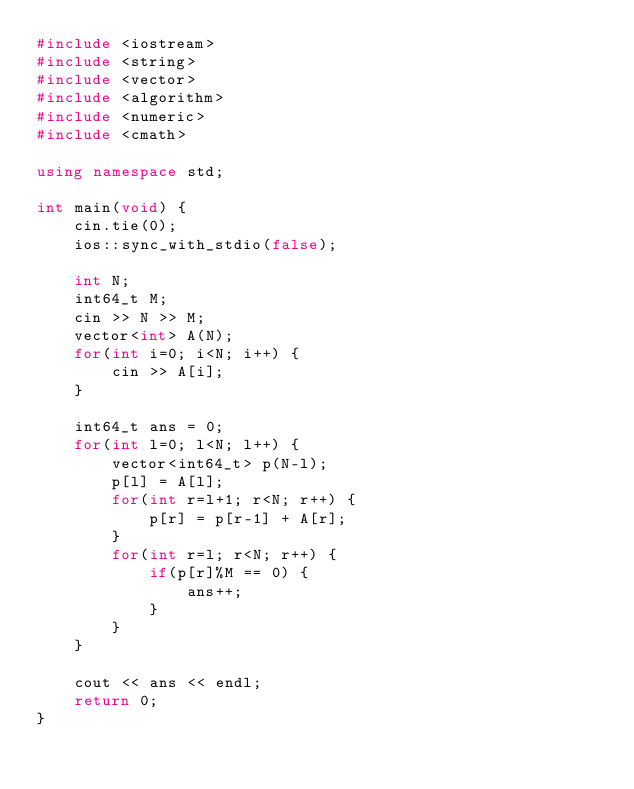Convert code to text. <code><loc_0><loc_0><loc_500><loc_500><_C++_>#include <iostream>
#include <string>
#include <vector>
#include <algorithm>
#include <numeric>
#include <cmath>

using namespace std;

int main(void) {
    cin.tie(0);
    ios::sync_with_stdio(false);

    int N;
    int64_t M;
    cin >> N >> M;
    vector<int> A(N);
    for(int i=0; i<N; i++) {
        cin >> A[i];
    }

    int64_t ans = 0;
    for(int l=0; l<N; l++) {
        vector<int64_t> p(N-l);
        p[l] = A[l];
        for(int r=l+1; r<N; r++) {
            p[r] = p[r-1] + A[r];
        }
        for(int r=l; r<N; r++) {
            if(p[r]%M == 0) {
                ans++;
            }
        }
    }

    cout << ans << endl;
    return 0;
}
</code> 